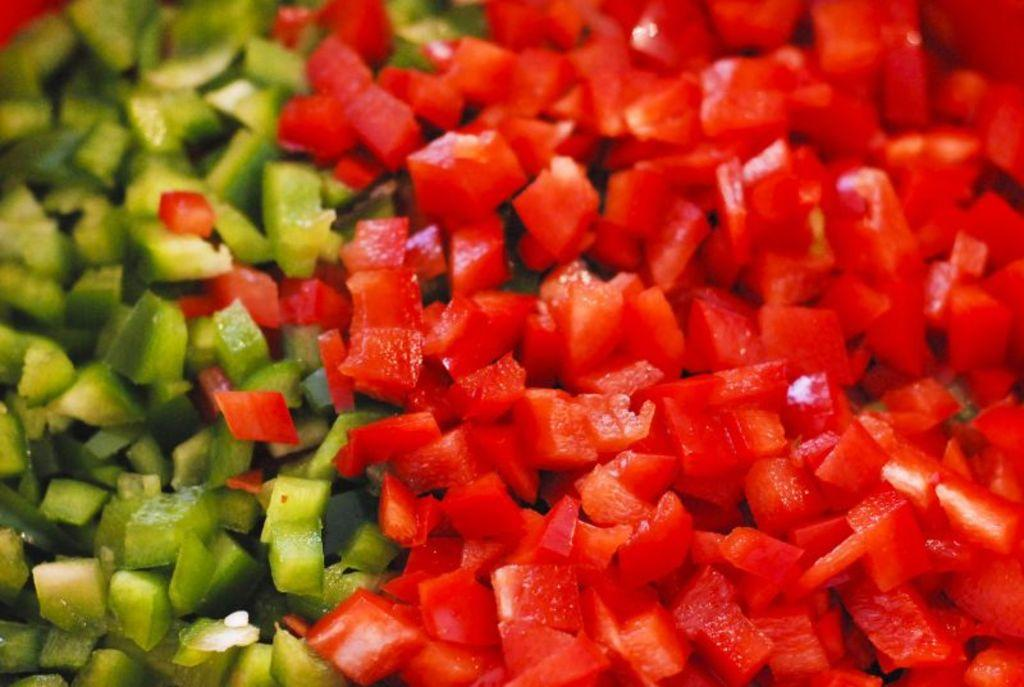What type of vegetable is present in the image? There are red and green bell peppers in the image. What color are the red bell peppers in the image? The red bell peppers in the image are chopped and have a red color. What color are the green bell peppers in the image? The green bell peppers in the image are chopped and have a green color. Where is the playground located in the image? There is no playground present in the image; it features chopped red and green bell peppers. What unit of measurement is used to describe the size of the bell peppers in the image? The size of the bell peppers in the image is not described in terms of a specific unit of measurement. 